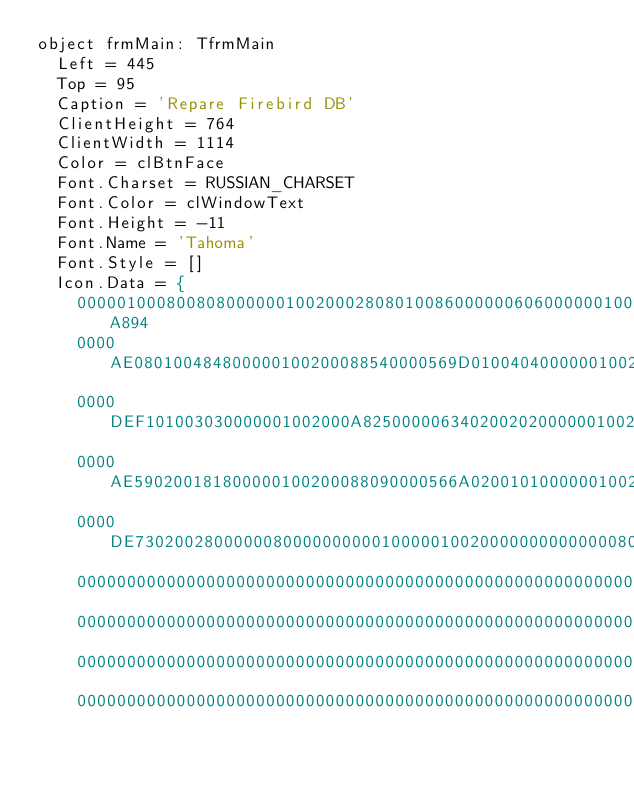<code> <loc_0><loc_0><loc_500><loc_500><_Pascal_>object frmMain: TfrmMain
  Left = 445
  Top = 95
  Caption = 'Repare Firebird DB'
  ClientHeight = 764
  ClientWidth = 1114
  Color = clBtnFace
  Font.Charset = RUSSIAN_CHARSET
  Font.Color = clWindowText
  Font.Height = -11
  Font.Name = 'Tahoma'
  Font.Style = []
  Icon.Data = {
    000001000800808000000100200028080100860000006060000001002000A894
    0000AE080100484800000100200088540000569D010040400000010020002842
    0000DEF101003030000001002000A8250000063402002020000001002000A810
    0000AE590200181800000100200088090000566A020010100000010020006804
    0000DE7302002800000080000000000100000100200000000000000801000000
    0000000000000000000000000000000000000000000000000000000000000000
    0000000000000000000000000000000000000000000000000000000000000000
    0000000000000000000000000000000000000000000000000000000000000000
    0000000000000000000000000000000000000000000000000000000000000000</code> 